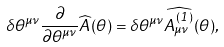<formula> <loc_0><loc_0><loc_500><loc_500>\delta \theta ^ { \mu \nu } \frac { \partial } { \partial \theta ^ { \mu \nu } } \widehat { A } ( \theta ) = \delta \theta ^ { \mu \nu } \widehat { A ^ { ( 1 ) } _ { \mu \nu } } ( \theta ) ,</formula> 